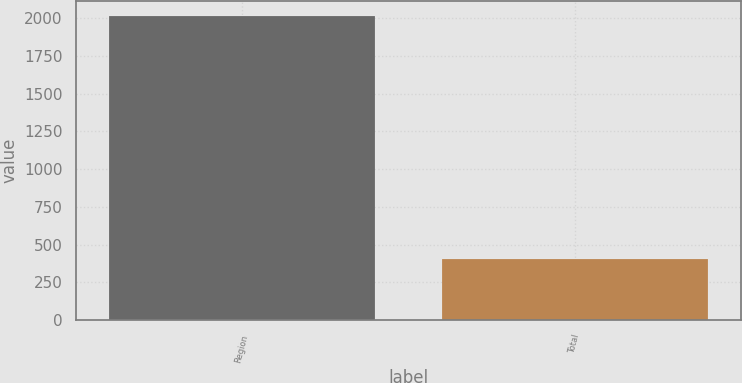<chart> <loc_0><loc_0><loc_500><loc_500><bar_chart><fcel>Region<fcel>Total<nl><fcel>2010<fcel>403<nl></chart> 